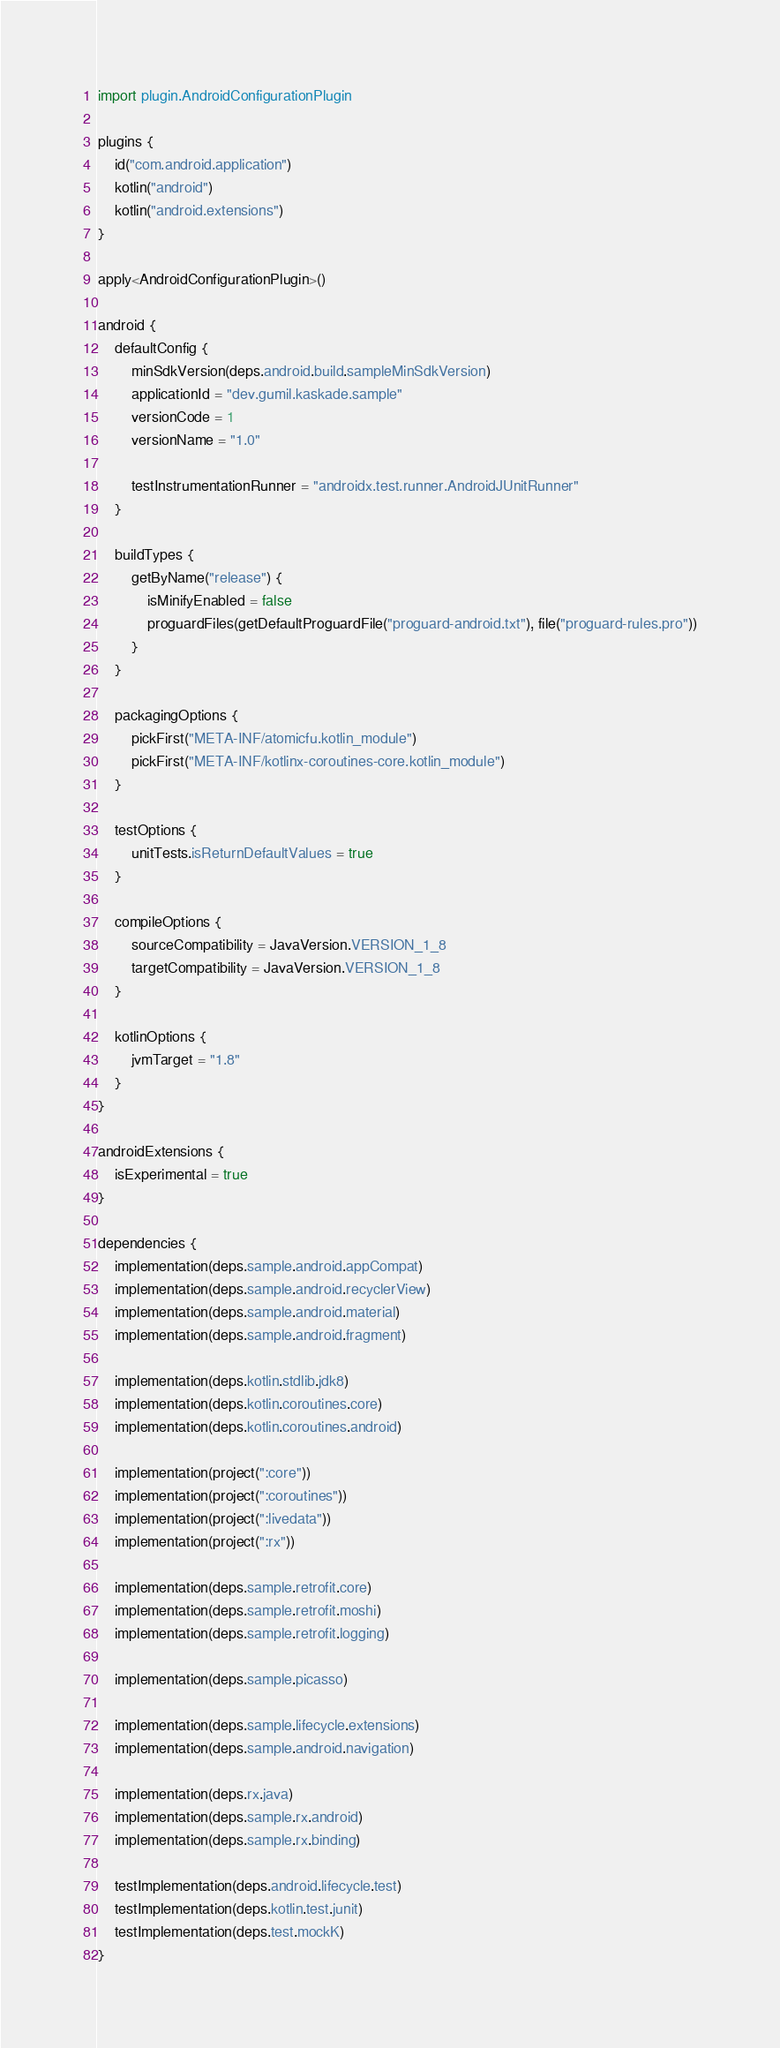Convert code to text. <code><loc_0><loc_0><loc_500><loc_500><_Kotlin_>import plugin.AndroidConfigurationPlugin

plugins {
    id("com.android.application")
    kotlin("android")
    kotlin("android.extensions")
}

apply<AndroidConfigurationPlugin>()

android {
    defaultConfig {
        minSdkVersion(deps.android.build.sampleMinSdkVersion)
        applicationId = "dev.gumil.kaskade.sample"
        versionCode = 1
        versionName = "1.0"

        testInstrumentationRunner = "androidx.test.runner.AndroidJUnitRunner"
    }

    buildTypes {
        getByName("release") {
            isMinifyEnabled = false
            proguardFiles(getDefaultProguardFile("proguard-android.txt"), file("proguard-rules.pro"))
        }
    }

    packagingOptions {
        pickFirst("META-INF/atomicfu.kotlin_module")
        pickFirst("META-INF/kotlinx-coroutines-core.kotlin_module")
    }

    testOptions {
        unitTests.isReturnDefaultValues = true
    }

    compileOptions {
        sourceCompatibility = JavaVersion.VERSION_1_8
        targetCompatibility = JavaVersion.VERSION_1_8
    }

    kotlinOptions {
        jvmTarget = "1.8"
    }
}

androidExtensions {
    isExperimental = true
}

dependencies {
    implementation(deps.sample.android.appCompat)
    implementation(deps.sample.android.recyclerView)
    implementation(deps.sample.android.material)
    implementation(deps.sample.android.fragment)

    implementation(deps.kotlin.stdlib.jdk8)
    implementation(deps.kotlin.coroutines.core)
    implementation(deps.kotlin.coroutines.android)

    implementation(project(":core"))
    implementation(project(":coroutines"))
    implementation(project(":livedata"))
    implementation(project(":rx"))

    implementation(deps.sample.retrofit.core)
    implementation(deps.sample.retrofit.moshi)
    implementation(deps.sample.retrofit.logging)

    implementation(deps.sample.picasso)

    implementation(deps.sample.lifecycle.extensions)
    implementation(deps.sample.android.navigation)

    implementation(deps.rx.java)
    implementation(deps.sample.rx.android)
    implementation(deps.sample.rx.binding)

    testImplementation(deps.android.lifecycle.test)
    testImplementation(deps.kotlin.test.junit)
    testImplementation(deps.test.mockK)
}
</code> 